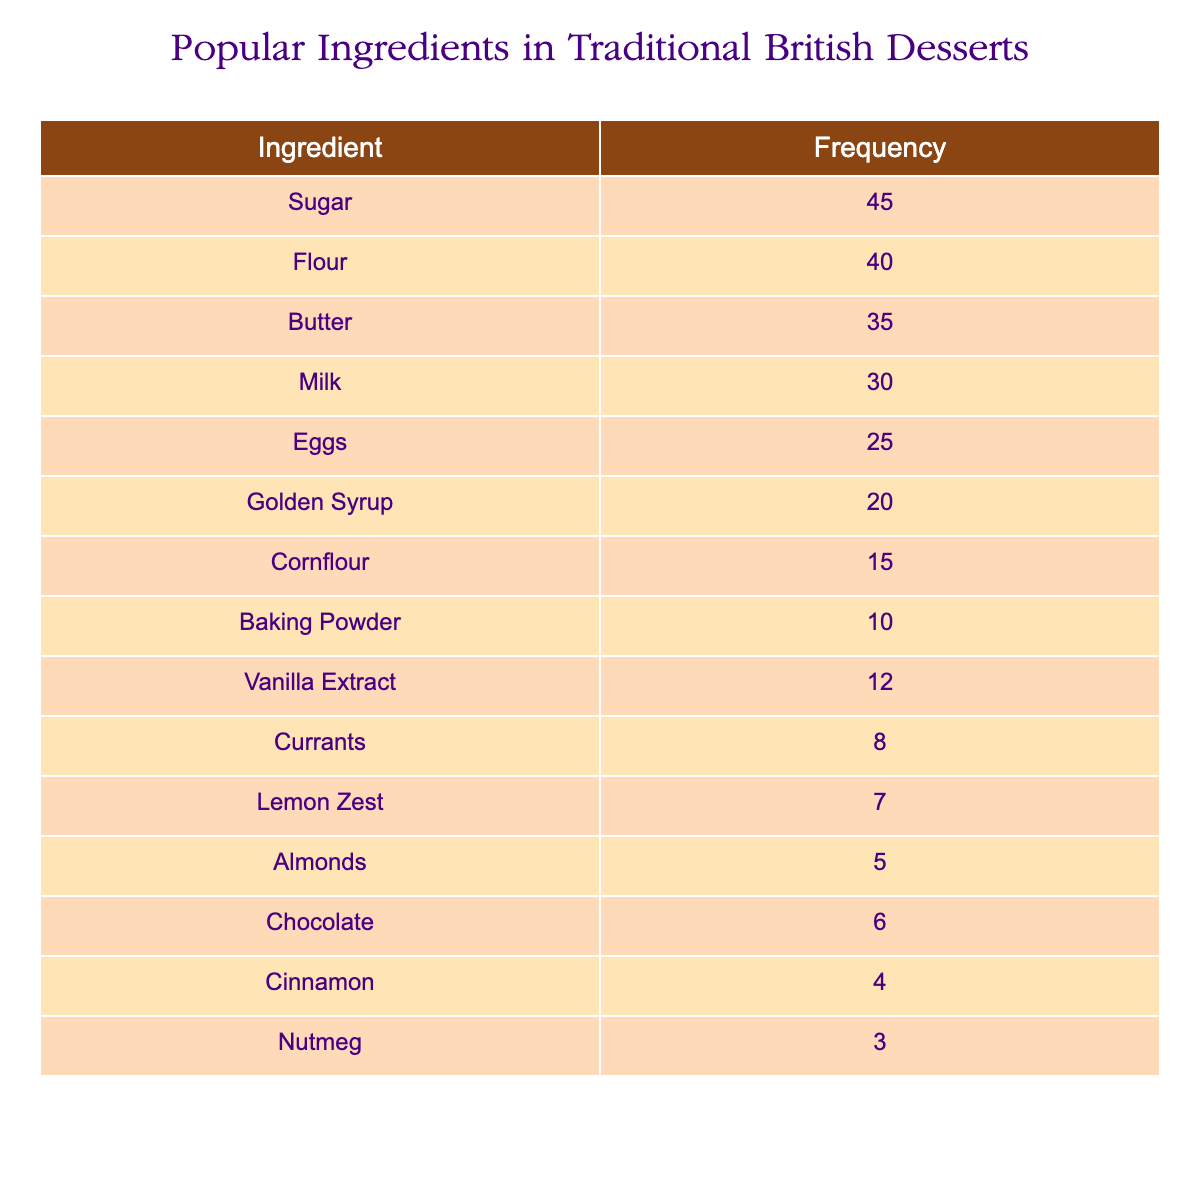What ingredient has the highest frequency? By examining the frequency distribution table, we see that "Sugar" has the highest frequency of 45, which is greater than any other ingredient listed.
Answer: Sugar How many ingredients have a frequency greater than 20? Looking at the table, we count the ingredients with frequencies higher than 20: Sugar (45), Flour (40), Butter (35), Milk (30), and Golden Syrup (20). This totals five ingredients.
Answer: 5 What is the total frequency of all the ingredients combined? To find the total frequency, we add all the individual frequencies: 45 (Sugar) + 40 (Flour) + 35 (Butter) + 30 (Milk) + 25 (Eggs) + 20 (Golden Syrup) + 15 (Cornflour) + 10 (Baking Powder) + 12 (Vanilla Extract) + 8 (Currants) + 7 (Lemon Zest) + 5 (Almonds) + 6 (Chocolate) + 4 (Cinnamon) + 3 (Nutmeg) =  34 + 70 + 85 = 256.
Answer: 256 True or false: Eggs are used more frequently than Golden Syrup. By comparing their frequencies, Eggs have a frequency of 25 and Golden Syrup has a frequency of 20. Since 25 is greater than 20, the statement is true.
Answer: True What is the difference in frequency between the most and least used ingredients? The most used ingredient is Sugar with a frequency of 45, and the least used ingredient is Nutmeg with a frequency of 3. To find the difference, we subtract: 45 - 3 = 42.
Answer: 42 How many ingredients have a frequency less than 10? From the table, we check the ingredients with frequencies under 10: Cinnamon (4) and Nutmeg (3). Thus, there are two ingredients below this threshold.
Answer: 2 Which ingredient has the second highest frequency? After identifying the ingredient with the highest frequency (Sugar at 45), we look for the next highest frequency, which is Flour at 40.
Answer: Flour What is the average frequency of the ingredients listed? To calculate the average frequency, we first need the total frequency (256), as previously calculated, and then divide by the number of ingredients (15): 256 / 15 = approximately 17.07.
Answer: 17.07 